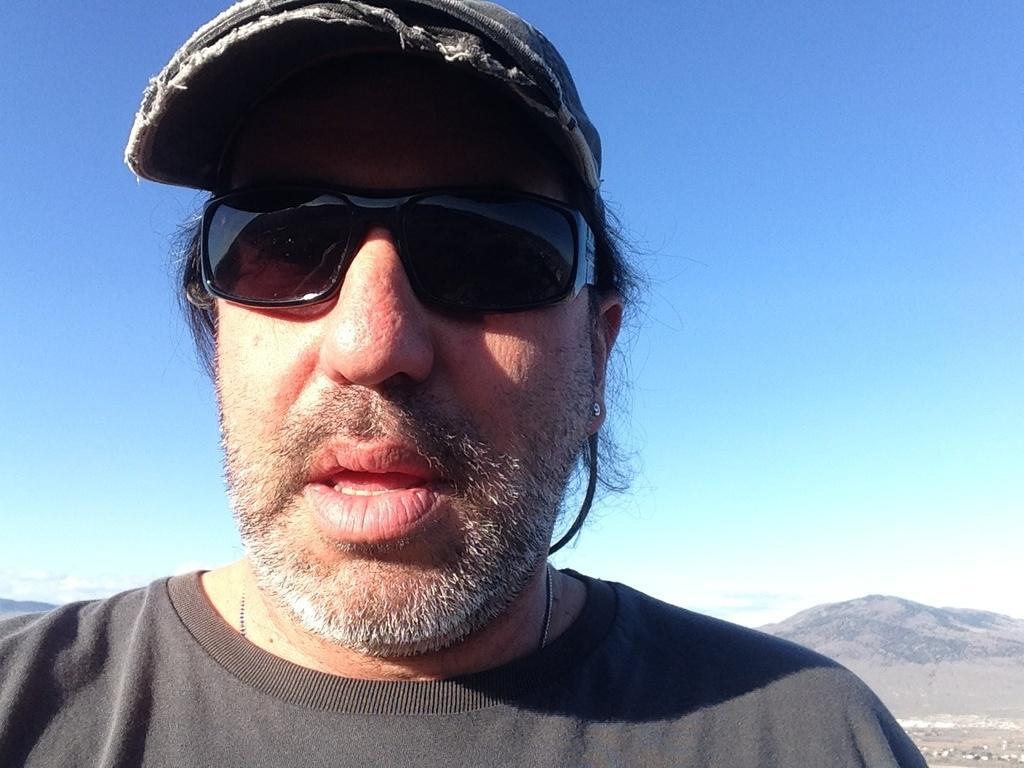Can you describe this image briefly? In this image we can see a man, who is wearing black color t-shirt, goggle and cap. Behind mountains and sky is there. 